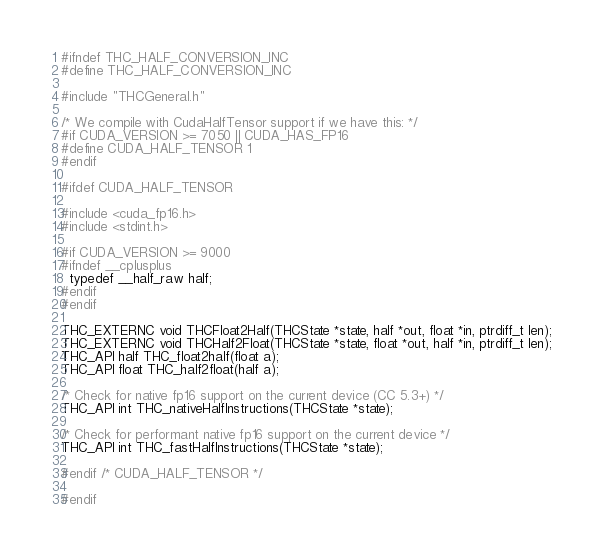<code> <loc_0><loc_0><loc_500><loc_500><_C_>#ifndef THC_HALF_CONVERSION_INC
#define THC_HALF_CONVERSION_INC

#include "THCGeneral.h"

/* We compile with CudaHalfTensor support if we have this: */
#if CUDA_VERSION >= 7050 || CUDA_HAS_FP16
#define CUDA_HALF_TENSOR 1
#endif

#ifdef CUDA_HALF_TENSOR

#include <cuda_fp16.h>
#include <stdint.h>

#if CUDA_VERSION >= 9000
#ifndef __cplusplus
  typedef __half_raw half;
#endif
#endif

THC_EXTERNC void THCFloat2Half(THCState *state, half *out, float *in, ptrdiff_t len);
THC_EXTERNC void THCHalf2Float(THCState *state, float *out, half *in, ptrdiff_t len);
THC_API half THC_float2half(float a);
THC_API float THC_half2float(half a);

/* Check for native fp16 support on the current device (CC 5.3+) */
THC_API int THC_nativeHalfInstructions(THCState *state);

/* Check for performant native fp16 support on the current device */
THC_API int THC_fastHalfInstructions(THCState *state);

#endif /* CUDA_HALF_TENSOR */

#endif
</code> 